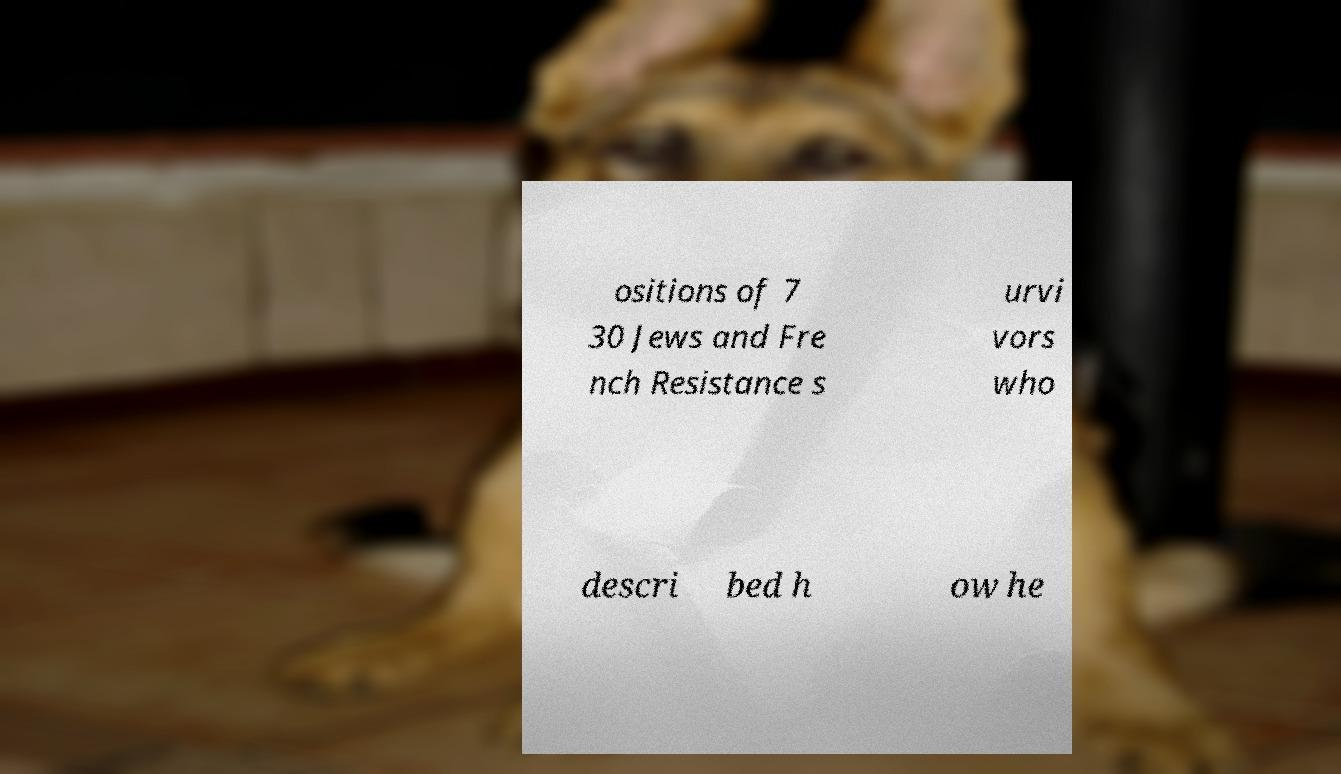Could you extract and type out the text from this image? ositions of 7 30 Jews and Fre nch Resistance s urvi vors who descri bed h ow he 